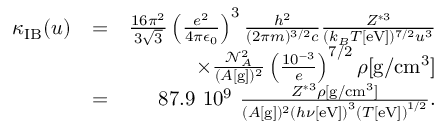<formula> <loc_0><loc_0><loc_500><loc_500>\begin{array} { r l r } { \kappa _ { I B } ( u ) } & { = } & { \frac { 1 6 \pi ^ { 2 } } { 3 \sqrt { 3 } } \left ( \frac { e ^ { 2 } } { 4 \pi \epsilon _ { 0 } } \right ) ^ { 3 } \frac { h ^ { 2 } } { ( 2 \pi m ) ^ { 3 / 2 } c } \frac { Z ^ { * 3 } } { ( k _ { B } T [ e V ] ) ^ { 7 / 2 } u ^ { 3 } } } \\ & { \times \frac { \mathcal { N } _ { A } ^ { 2 } } { ( A [ g ] ) ^ { 2 } } \left ( \frac { 1 0 ^ { - 3 } } { e } \right ) ^ { 7 / 2 } \rho [ g / c m ^ { 3 } ] } \\ & { = } & { 8 7 . 9 1 0 ^ { 9 } \frac { Z ^ { * 3 } \rho [ g / c m ^ { 3 } ] } { ( A [ g ] ) ^ { 2 } \left ( h \nu [ e V ] \right ) ^ { 3 } \left ( T [ e V ] \right ) ^ { 1 / 2 } } . } \end{array}</formula> 